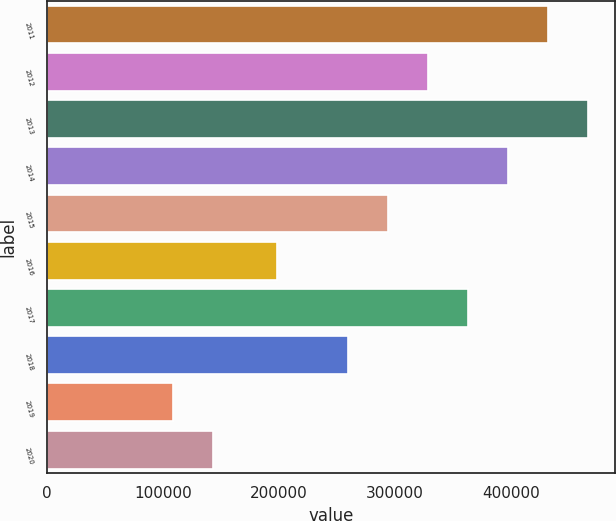<chart> <loc_0><loc_0><loc_500><loc_500><bar_chart><fcel>2011<fcel>2012<fcel>2013<fcel>2014<fcel>2015<fcel>2016<fcel>2017<fcel>2018<fcel>2019<fcel>2020<nl><fcel>432500<fcel>329000<fcel>467000<fcel>398000<fcel>294500<fcel>198000<fcel>363500<fcel>260000<fcel>109000<fcel>143500<nl></chart> 